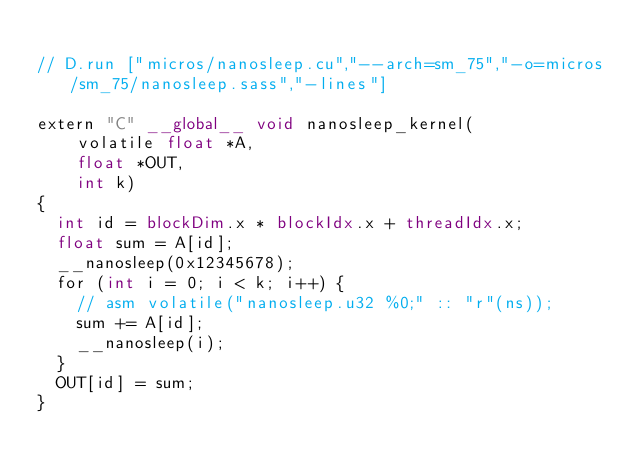Convert code to text. <code><loc_0><loc_0><loc_500><loc_500><_Cuda_>
// D.run ["micros/nanosleep.cu","--arch=sm_75","-o=micros/sm_75/nanosleep.sass","-lines"]

extern "C" __global__ void nanosleep_kernel(
    volatile float *A,
    float *OUT,
    int k)
{
  int id = blockDim.x * blockIdx.x + threadIdx.x;
  float sum = A[id];
  __nanosleep(0x12345678);
  for (int i = 0; i < k; i++) {
    // asm volatile("nanosleep.u32 %0;" :: "r"(ns));
    sum += A[id];
    __nanosleep(i);
  }
  OUT[id] = sum;
}</code> 